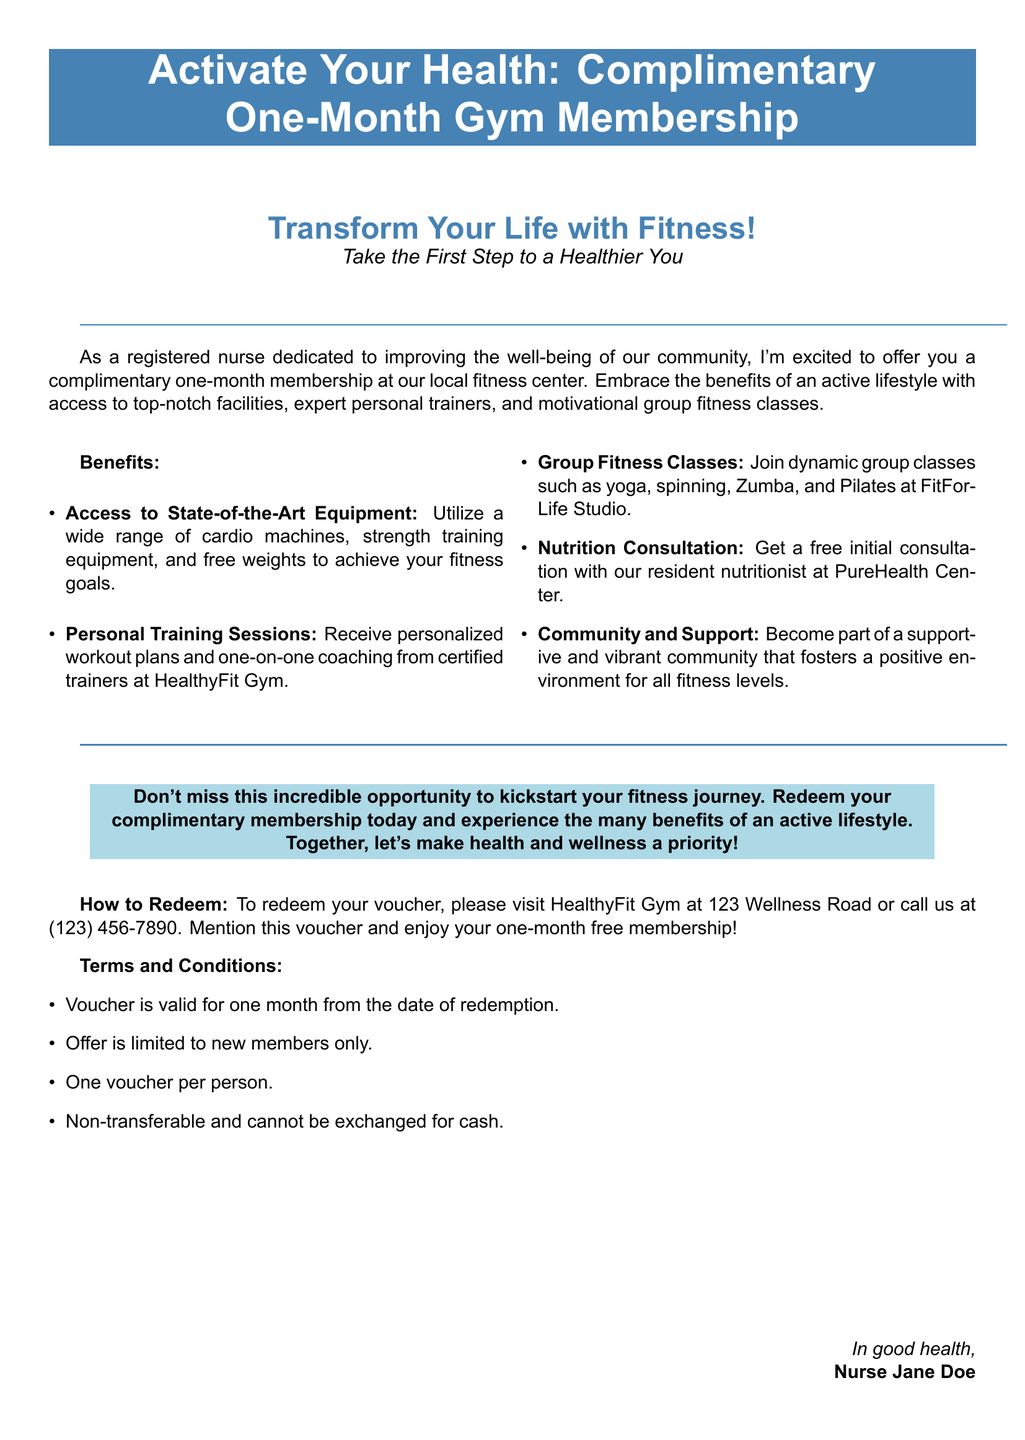What is the title of the voucher? The title of the voucher is prominently displayed at the top of the document.
Answer: Activate Your Health: Complimentary One-Month Gym Membership Who offers the gym membership? The document identifies the person making the offer.
Answer: Nurse Jane Doe How long is the gym membership valid? The document states the duration for which the membership can be utilized.
Answer: One month What type of classes are included in the membership? The document lists various classes that members can attend.
Answer: Group fitness classes Where do you redeem the voucher? The document specifies the location where the voucher can be utilized.
Answer: HealthyFit Gym at 123 Wellness Road Is the voucher transferable? The document includes terms that indicate the nature of the voucher concerning transfers.
Answer: Non-transferable What is one benefit of this gym membership? The document mentions multiple benefits available with the membership.
Answer: Access to State-of-the-Art Equipment What is included in the nutrition consultation? The document highlights an offering related to nutrition as part of the membership.
Answer: Free initial consultation 